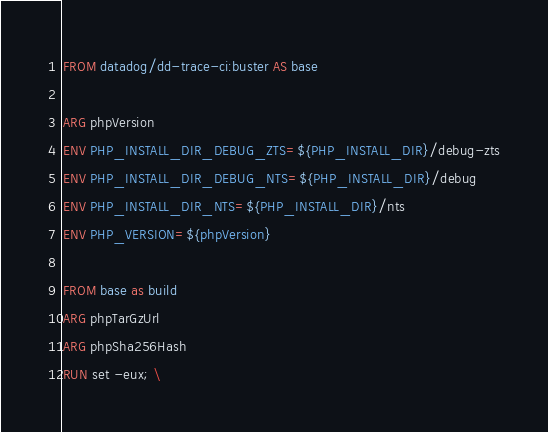<code> <loc_0><loc_0><loc_500><loc_500><_Dockerfile_>FROM datadog/dd-trace-ci:buster AS base

ARG phpVersion
ENV PHP_INSTALL_DIR_DEBUG_ZTS=${PHP_INSTALL_DIR}/debug-zts
ENV PHP_INSTALL_DIR_DEBUG_NTS=${PHP_INSTALL_DIR}/debug
ENV PHP_INSTALL_DIR_NTS=${PHP_INSTALL_DIR}/nts
ENV PHP_VERSION=${phpVersion}

FROM base as build
ARG phpTarGzUrl
ARG phpSha256Hash
RUN set -eux; \</code> 